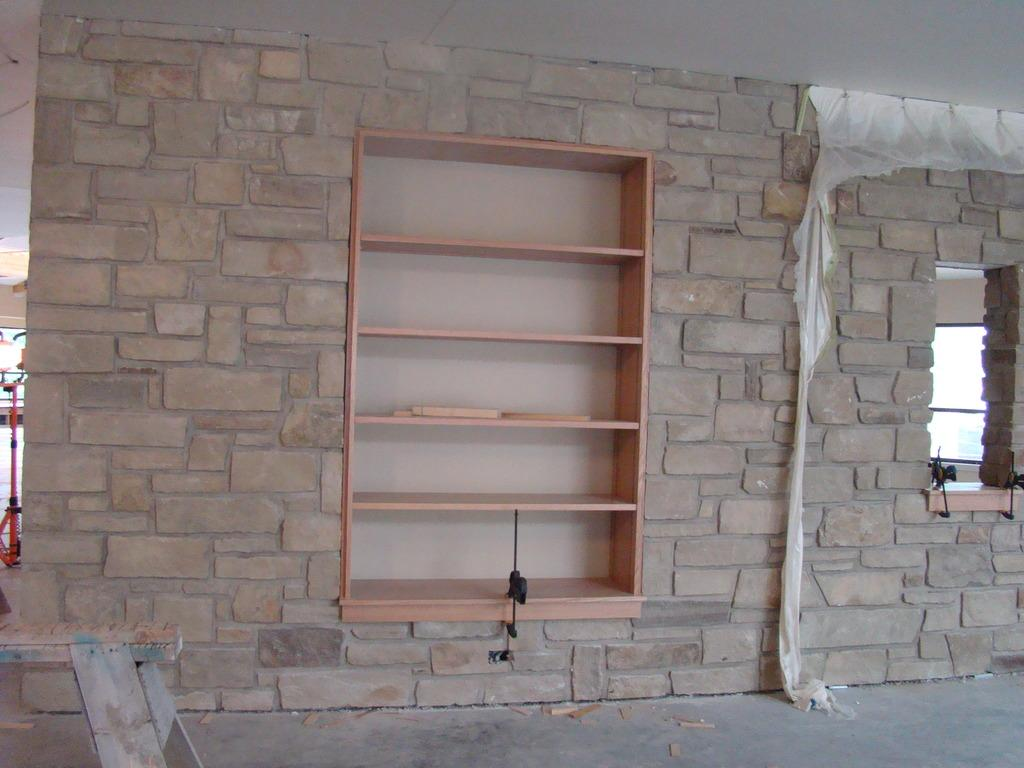What can be seen in the image that is used for holding or organizing items? There is a rack in the image that is used for holding or organizing items. What type of structure is visible in the background of the image? There is a wall in the image that serves as a background structure. How many oranges are on the design of the wall in the image? There is no mention of oranges or a design on the wall in the image. 